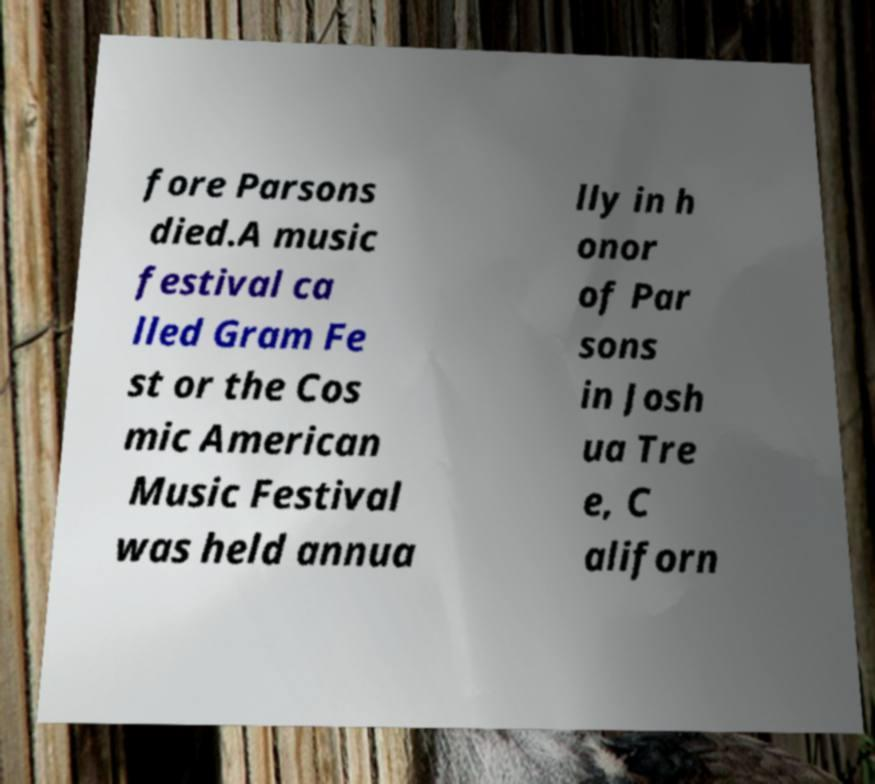For documentation purposes, I need the text within this image transcribed. Could you provide that? fore Parsons died.A music festival ca lled Gram Fe st or the Cos mic American Music Festival was held annua lly in h onor of Par sons in Josh ua Tre e, C aliforn 